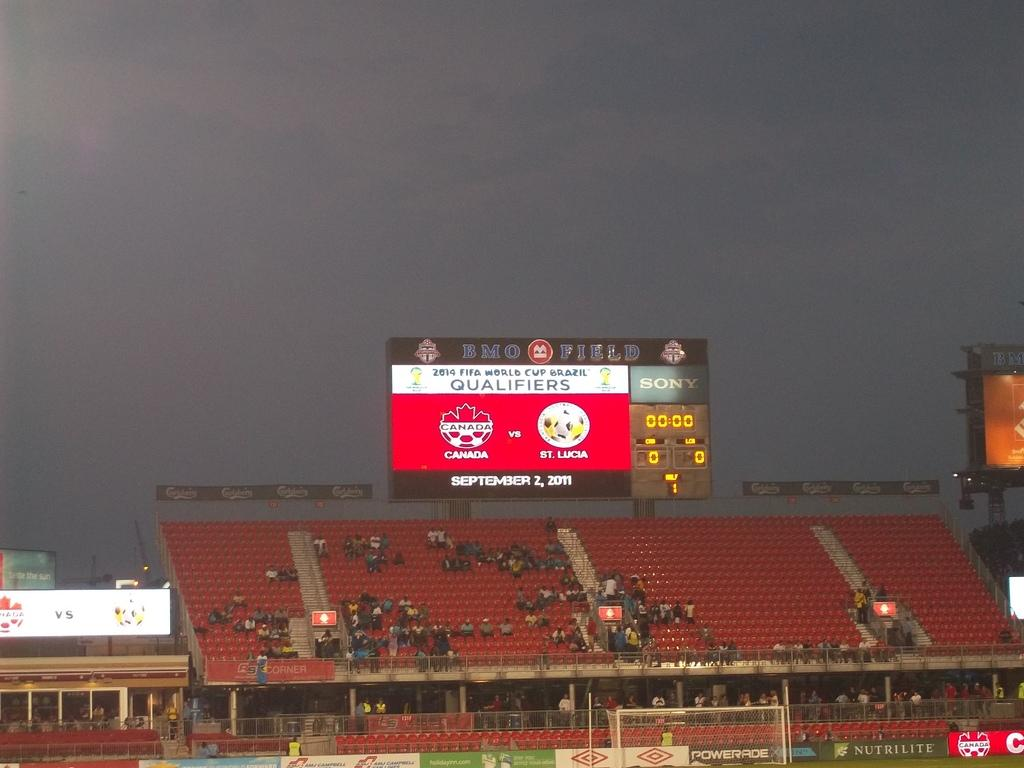<image>
Offer a succinct explanation of the picture presented. A sports stadium goes by the name of BMO Field. 